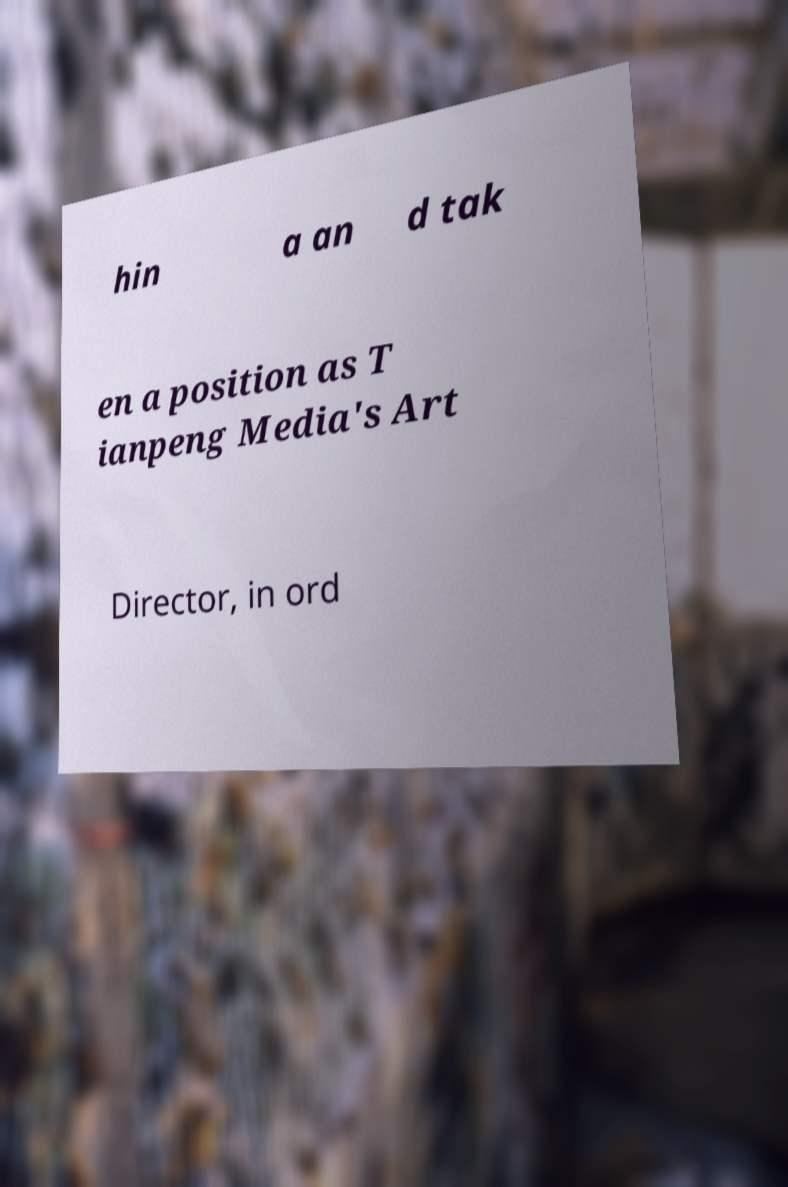Could you extract and type out the text from this image? hin a an d tak en a position as T ianpeng Media's Art Director, in ord 